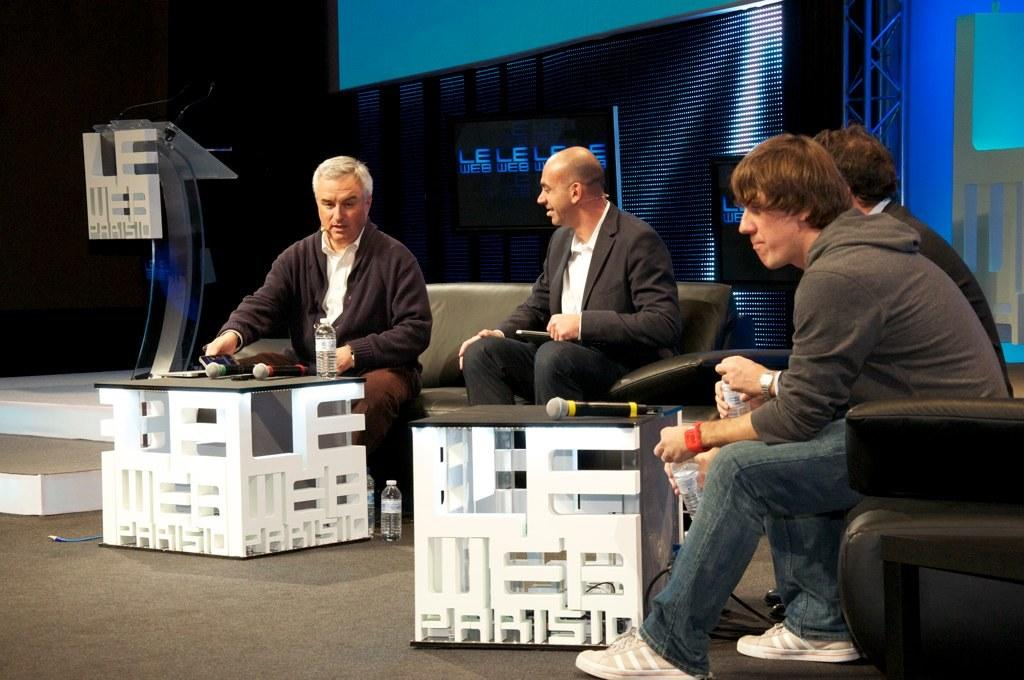<image>
Summarize the visual content of the image. 4 men sitting on chairs and couches talking, the text on the bottom says Parisio. 